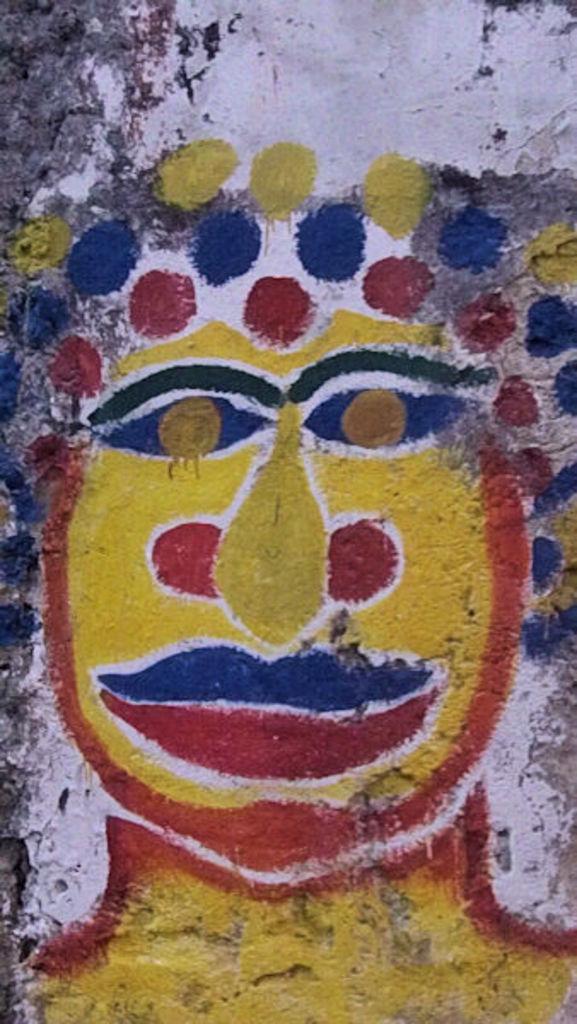In one or two sentences, can you explain what this image depicts? In this image there is a depiction on the wall. 